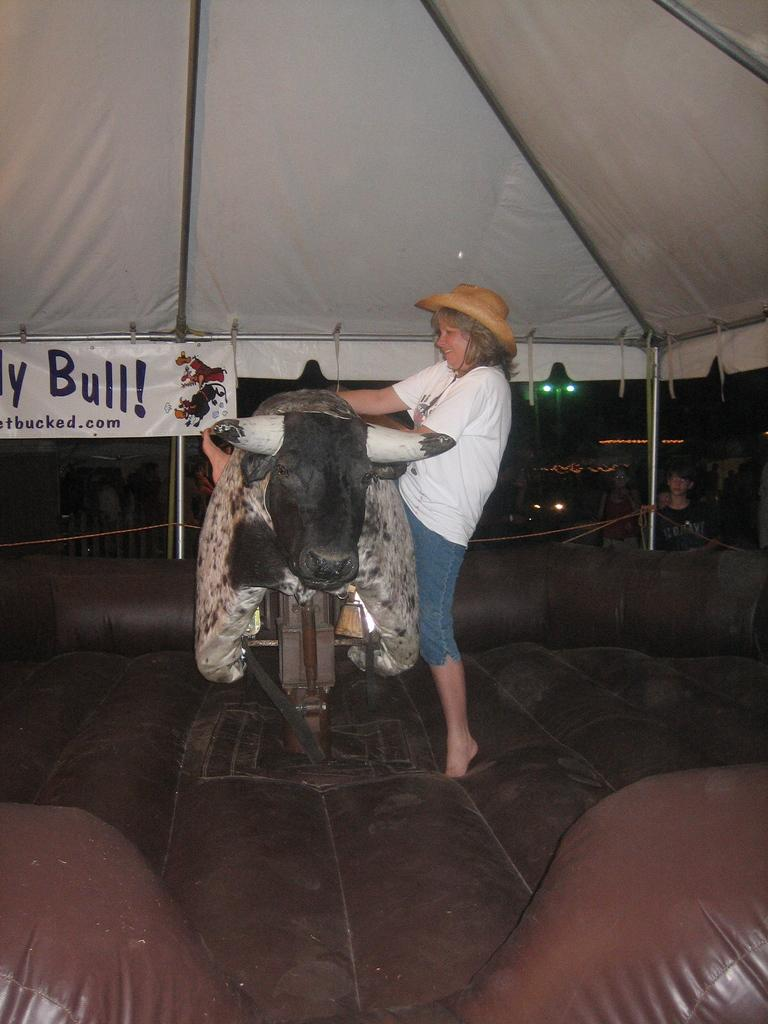What type of event is taking place in the image? The image depicts a rodeo bull game. Can you describe any people present in the image? Yes, there is a lady in the image. What type of mitten is the lady wearing in the image? There is no mitten visible in the image; the lady is not wearing any gloves or mittens. How many fingers does the lady have in the image? It is not possible to determine the exact number of fingers the lady has in the image, as her hands are not clearly visible. 